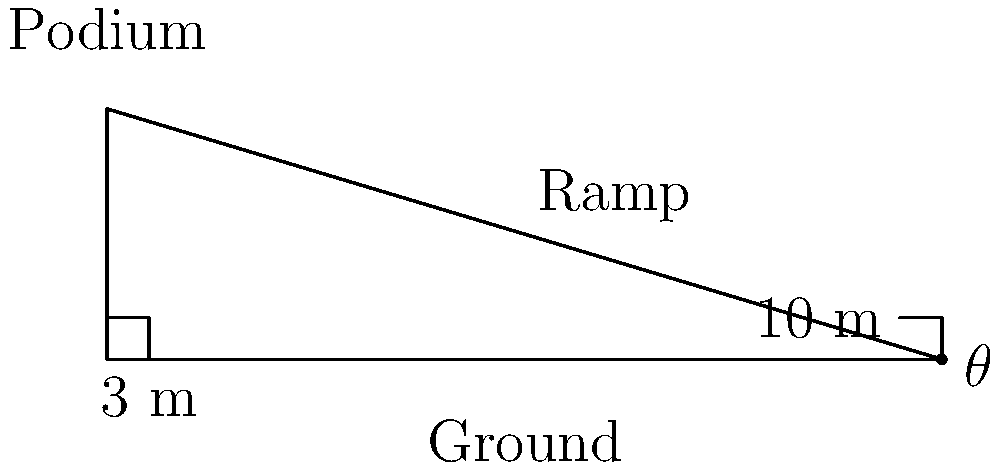As a veteran political activist, you are organizing a rally and need to set up a ramp for easy access to the podium. The podium is 3 meters high, and you have a 10-meter long ramp. What is the angle of inclination ($\theta$) of the ramp? To solve this problem, we'll use trigonometry. Let's approach this step-by-step:

1) We have a right-angled triangle where:
   - The opposite side (height of the podium) is 3 meters
   - The hypotenuse (length of the ramp) is 10 meters
   - We need to find the angle $\theta$

2) In a right-angled triangle, $\sin \theta = \frac{\text{opposite}}{\text{hypotenuse}}$

3) Substituting our values:
   $\sin \theta = \frac{3}{10}$

4) To find $\theta$, we need to take the inverse sine (arcsin) of both sides:
   $\theta = \arcsin(\frac{3}{10})$

5) Using a calculator or trigonometric tables:
   $\theta \approx 17.458$ degrees

6) Rounding to one decimal place:
   $\theta \approx 17.5$ degrees

This angle ensures a gradual ascent, making it easier for people of all ages to access the podium safely.
Answer: $17.5^\circ$ 